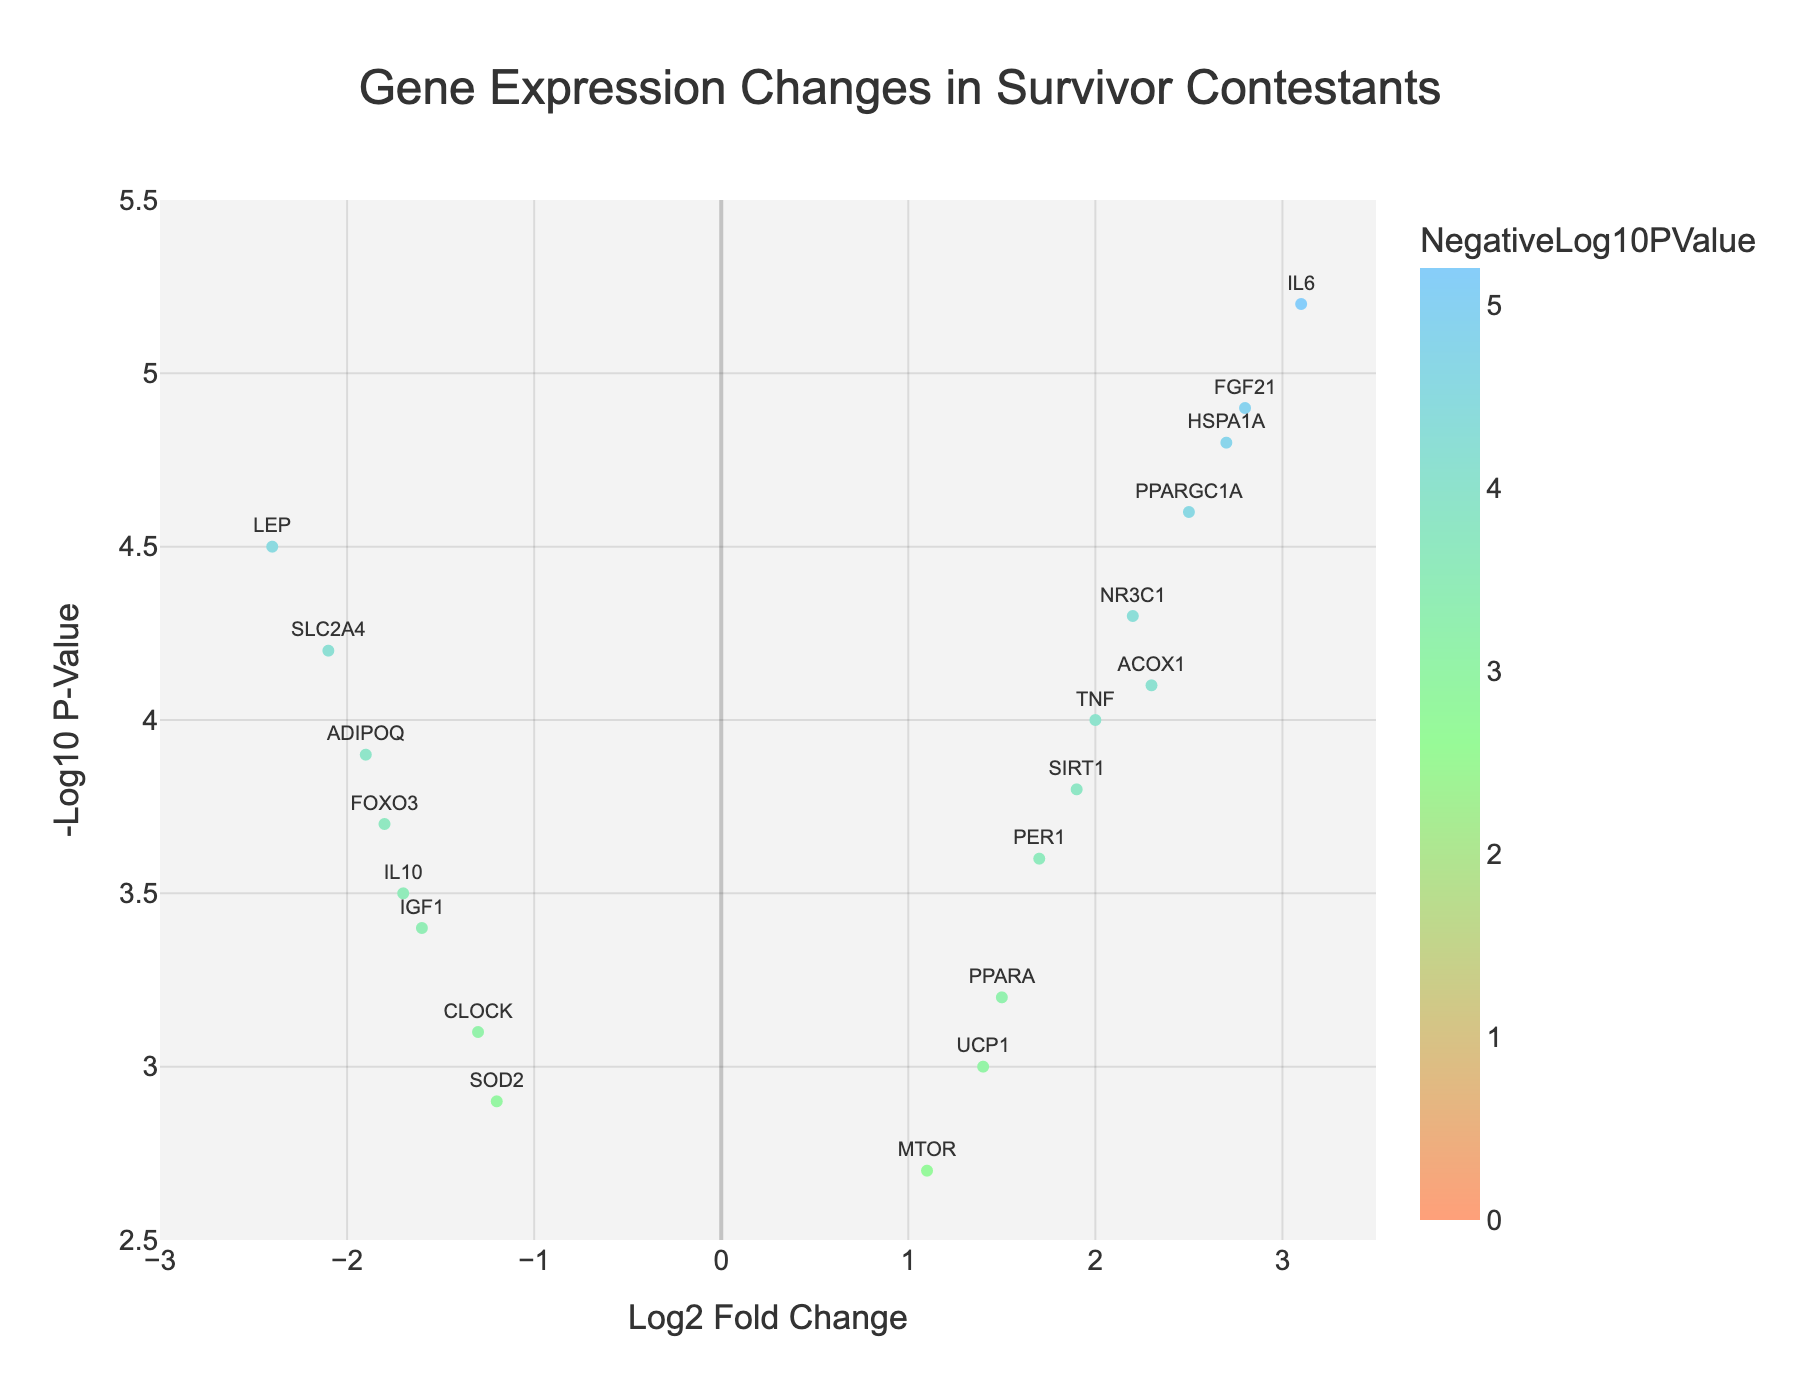How many genes have a positive Log2 Fold Change? To determine this, we count the number of data points (genes) with a positive Log2 Fold Change value. There are 10 data points in total with Log2 Fold Change values greater than 0.
Answer: 10 Which gene has the highest negative Log2 Fold Change and what is its value? From the plot, we identify the gene with the most negative Log2 Fold Change. LEP has the highest negative Log2 Fold Change with a value of -2.4.
Answer: LEP, -2.4 What is the significance threshold value indicated by the dashed red line? The significance threshold is represented by the horizontal dashed red line on the y-axis. We need to identify the y-axis value where this line is positioned. From the plot, the threshold is at approximately 1.3
Answer: 1.3 Which gene has the highest -Log10 P-Value? To find this, we look for the highest point on the y-axis. IL6 is at the highest point with a -Log10 P-Value of 5.2.
Answer: IL6, 5.2 How many genes are above the significance threshold? We count the number of data points above the red threshold line. There are 11 data points above this threshold.
Answer: 11 Which gene shows the most significant change in expression when considering both Log2 Fold Change and -Log10 P-Value? The gene with the highest -Log10 P-Value and either a high positive or negative Log2 Fold Change represents the most significant change. IL6 has the highest -Log10 P-Value (5.2) and a strong positive Log2 Fold Change (3.1), indicating it is the most significant.
Answer: IL6 Are there any genes with a -Log10 P-Value less than 2.7? Observing the y-axis, no data points are below the value of 2.7. Therefore, no genes fall into this range.
Answer: No Which gene has the smallest Log2 Fold Change among those with a -Log10 P-Value greater than the significance threshold? To solve this, we filter genes with a -Log10 P-Value above the threshold (~1.3) and identify the one with the smallest Log2 Fold Change. SOD2 with a Log2 Fold Change of -1.2 fits this criterion.
Answer: SOD2, -1.2 Are there more genes with positive or negative Log2 Fold Change values above the significance threshold? Count the number of positive and negative Log2 Fold Change values above the threshold (~1.3). There are 6 genes with positive Log2 Fold Change and 5 with negative Log2 Fold Change values above the threshold.
Answer: More with positive What is the Log2 Fold Change range of the genes that have -Log10 P-Values within the range of 4 to 5? Identify the genes within the 4 to 5 range on the y-axis and note their Log2 Fold Change values. The genes are ACOX1, LEP, HSPA1A, SLC2A4, and NR3C1, with Log2 Fold Change values ranging from -2.1 to 2.3.
Answer: -2.1 to 2.3 